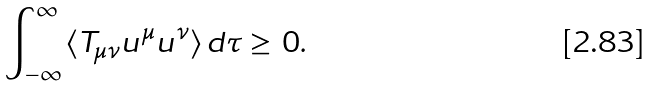<formula> <loc_0><loc_0><loc_500><loc_500>\int _ { - \infty } ^ { \infty } \, \langle T _ { \mu \nu } u ^ { \mu } u ^ { \nu } \rangle \, d \tau \geq \, 0 .</formula> 